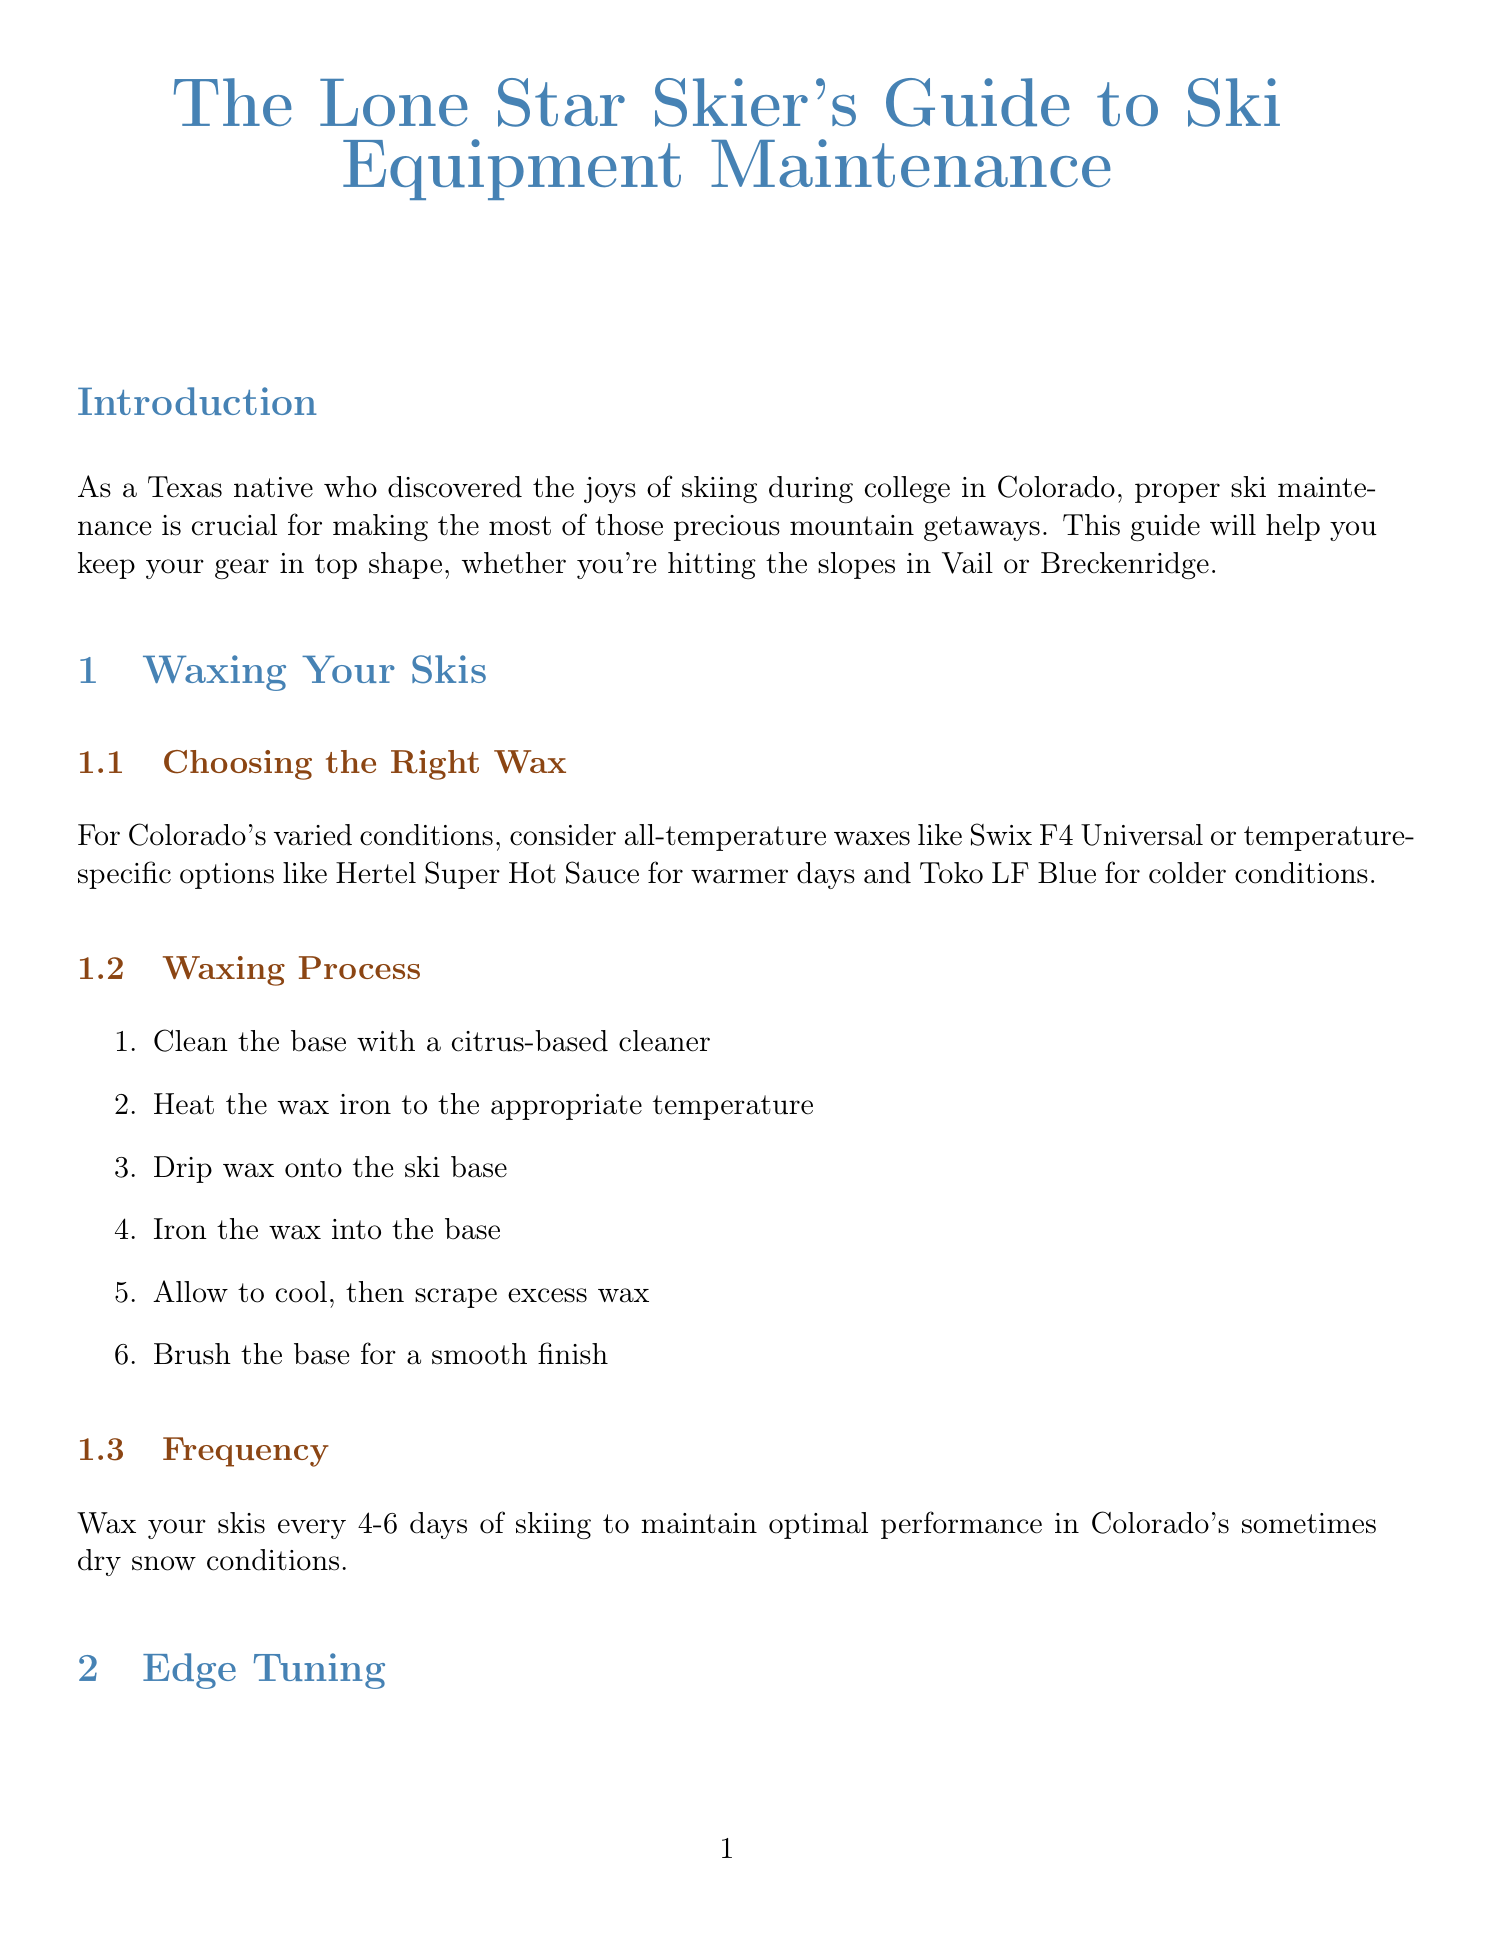What is the title of the guide? The title of the guide is indicated at the beginning of the document.
Answer: The Lone Star Skier's Guide to Ski Equipment Maintenance How often should you wax your skis according to the guide? The frequency for waxing skis is explicitly stated in the waxing section of the guide.
Answer: Every 4-6 days What is a recommended wax for warmer days? The guide lists specific waxes to use based on temperature in the waxing section.
Answer: Hertel Super Hot Sauce What edge angle is suggested for all-mountain skiing? The edge angle recommendation for tuning is specified in the edge tuning section.
Answer: 88-89 degrees What tool is suggested for precise edge work? The recommended tools for edge tuning can be found in the edge tuning section.
Answer: Swix Edge Tool What should you apply for off-season storage? The guide provides specific instructions on off-season storage in the storage section.
Answer: Storage wax Which Colorado ski shop is mentioned for professional tuning? A list of Colorado ski shops is provided, including recommendations for professional services.
Answer: Slope Style What type of wax should be used for off-season storage? The section on storage specifies what to use for protecting skis in storage.
Answer: Thick layer of storage wax Where can you find ski maintenance workshops? The guide mentions local resources for workshops and clinics in Colorado ski resorts.
Answer: Loveland Ski Area 